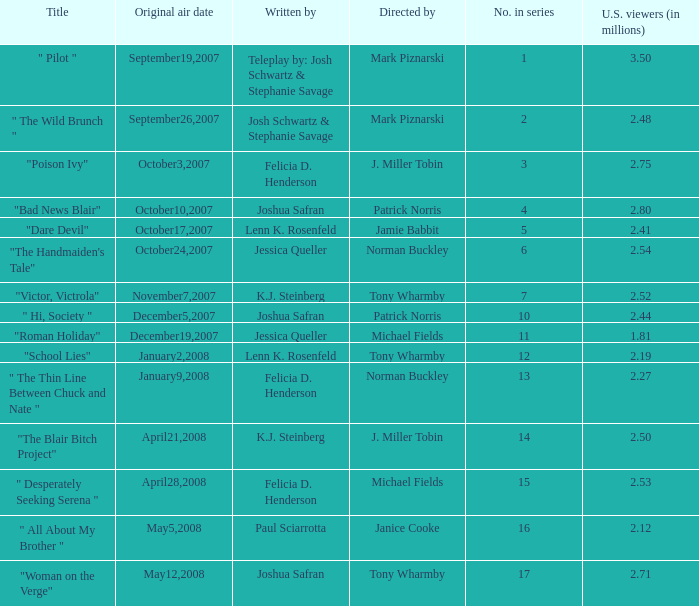What is the title when 2.50 is u.s. viewers (in millions)?  "The Blair Bitch Project". 